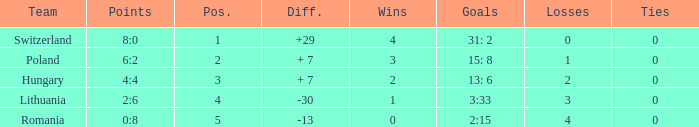Which team had fewer than 2 losses and a position number more than 1? Poland. 